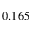<formula> <loc_0><loc_0><loc_500><loc_500>0 . 1 6 5</formula> 